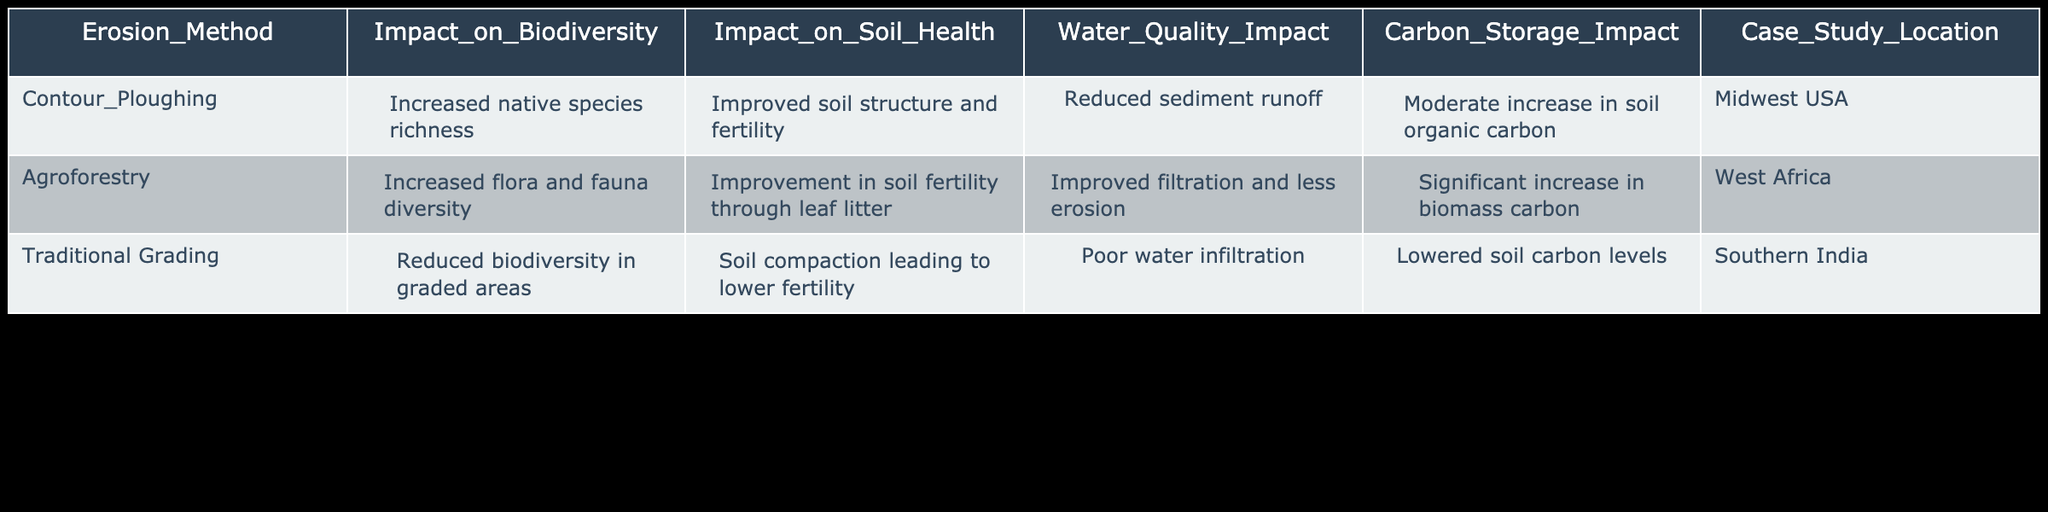What is the impact of Contour Ploughing on biodiversity? According to the table, Contour Ploughing leads to an increase in native species richness, indicating a positive impact on biodiversity.
Answer: Increased native species richness What is the location of the case study for Agroforestry? The case study for Agroforestry is located in West Africa, which is specified in the table under the Case Study Location column.
Answer: West Africa Is the impact of Traditional Grading on soil health described as positive or negative? The table states that Traditional Grading results in soil compaction leading to lower fertility, which indicates a negative impact on soil health.
Answer: Negative Which erosion method shows a significant increase in biomass carbon? The table mentions that Agroforestry shows a significant increase in biomass carbon, which is found in the Carbon Storage Impact column.
Answer: Agroforestry What is the average impact on Water Quality from the erosion methods listed in the table? The water quality impacts associated with the methods are Reduced sediment runoff, Improved filtration and less erosion, and Poor water infiltration. Calculating the average can be subjective based on qualitative descriptions; however, it can be inferred that Agroforestry has a positive impact while Traditional Grading has a negative one, making the general average water quality impact neutral to positive across the board depending on which methods are employed.
Answer: Generally neutral to positive Which erosion method has the most favorable overall impact on ecosystem health? To determine the most favorable method, we need to evaluate each erosion method considering biodiversity, soil health, water quality, and carbon storage. Agroforestry demonstrates increased biodiversity, improved soil health, better water quality, and significant biomass carbon storage compared to the other methods, indicating it has the most favorable overall impact on ecosystem health.
Answer: Agroforestry Do any of the methods lead to poor water infiltration? Yes, Traditional Grading is indicated in the table to lead to poor water infiltration, therefore the answer is yes for this fact-based question.
Answer: Yes Is there any method associated with improved soil structure and fertility? The table specifies that Contour Ploughing results in improved soil structure and fertility, therefore, the answer is yes.
Answer: Yes 